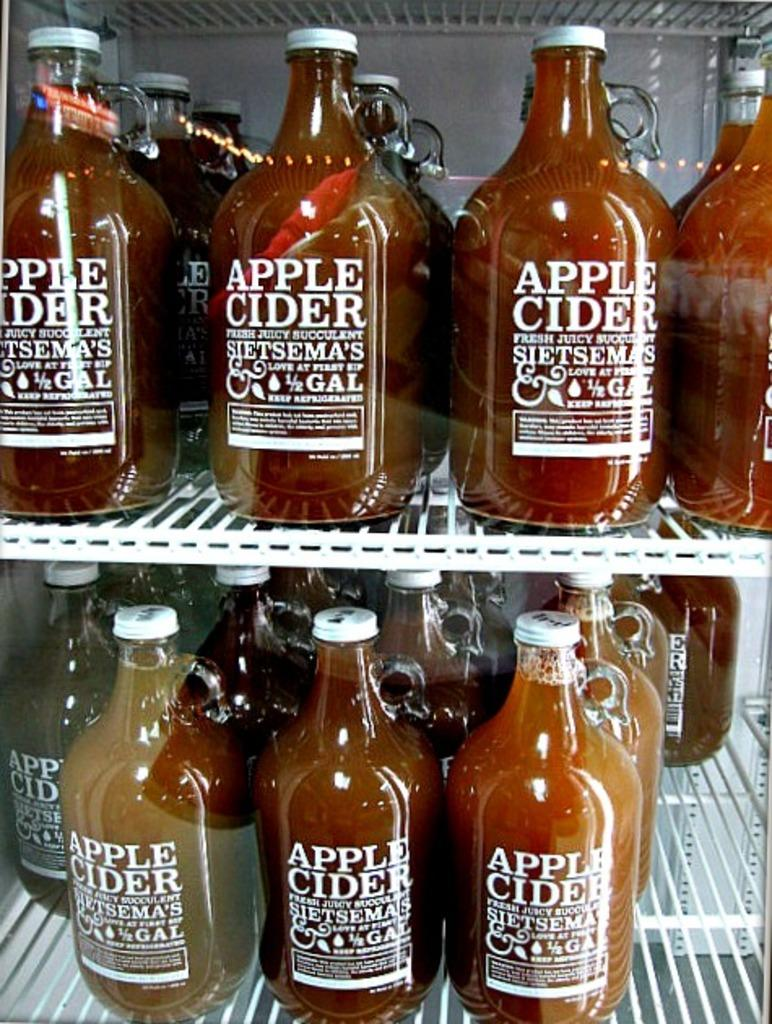What is the main subject of the image? The main subject of the image is many bottles. Where are the bottles located in the image? The bottles are on a rack in the image. What type of patch can be seen on the bottles in the image? There are no patches visible on the bottles in the image. What color is the ink used to write on the bottles in the image? There is no writing or ink present on the bottles in the image. 